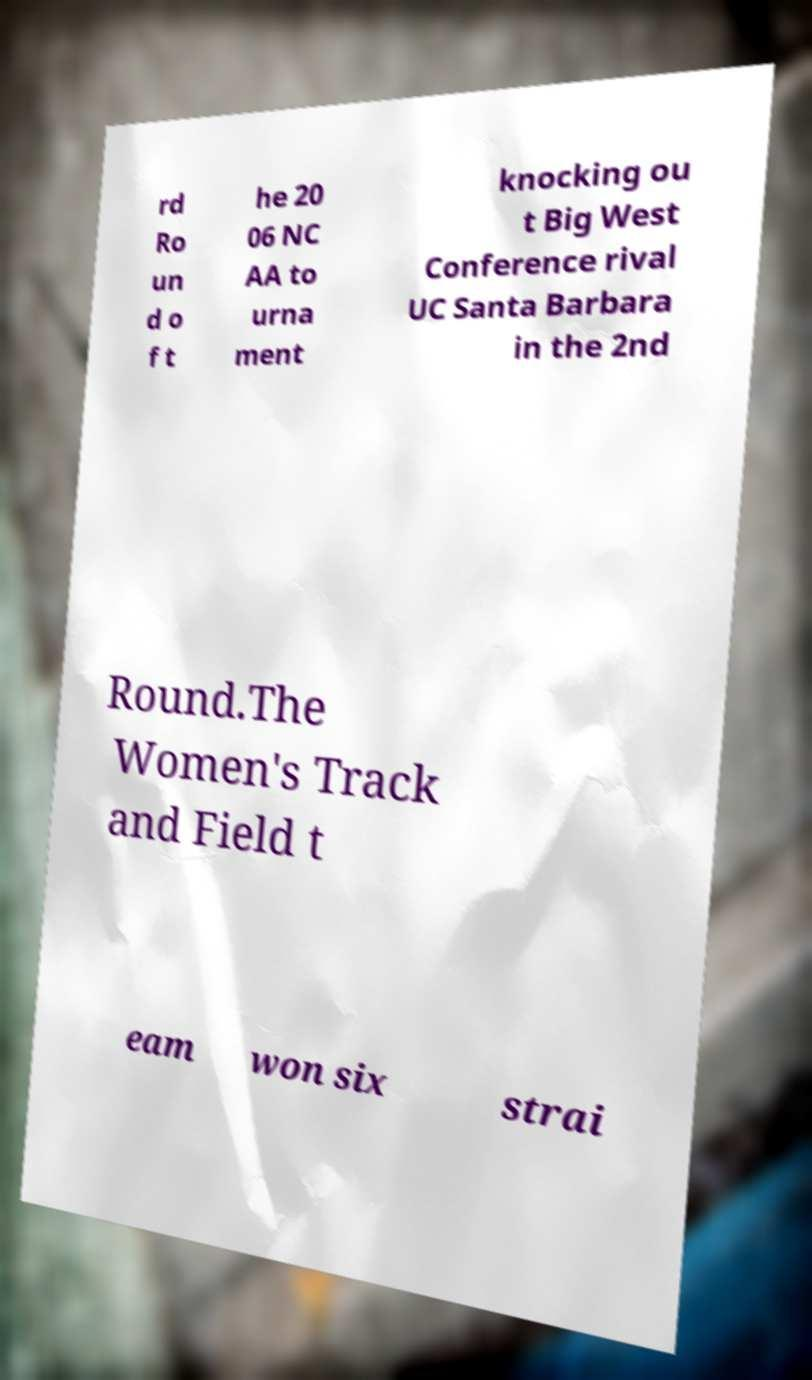Can you accurately transcribe the text from the provided image for me? rd Ro un d o f t he 20 06 NC AA to urna ment knocking ou t Big West Conference rival UC Santa Barbara in the 2nd Round.The Women's Track and Field t eam won six strai 